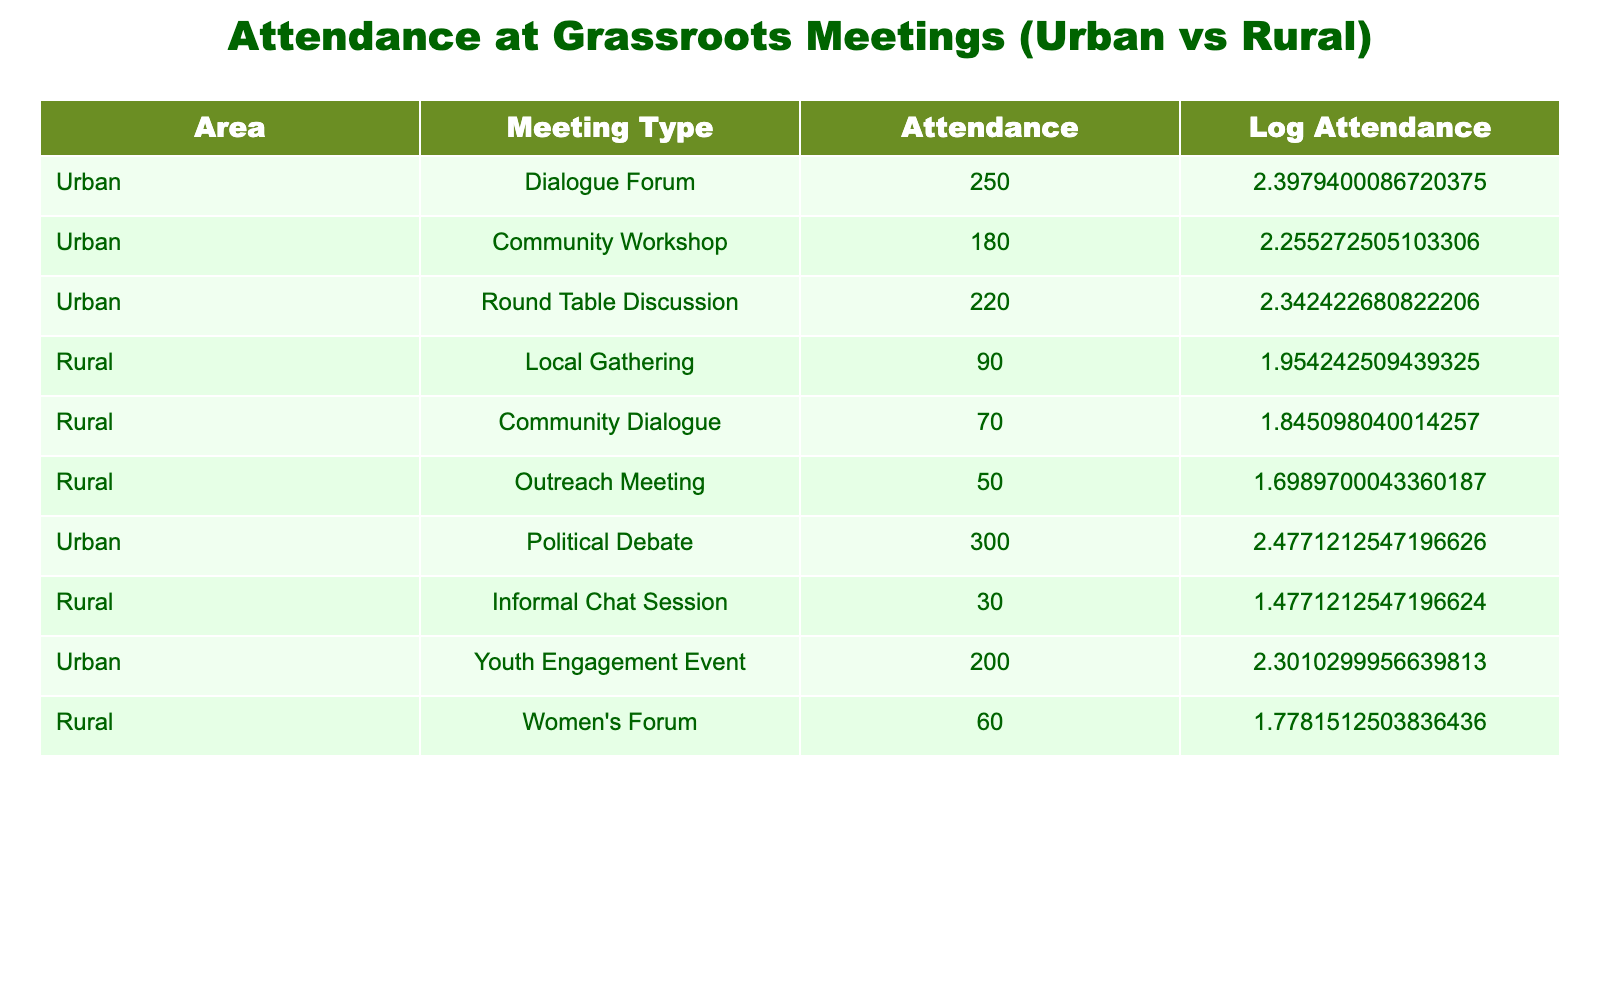What is the total attendance for urban meetings? To find the total attendance for urban meetings, sum the attendance values for all urban meeting types: 250 (Dialogue Forum) + 180 (Community Workshop) + 220 (Round Table Discussion) + 300 (Political Debate) + 200 (Youth Engagement Event) = 1150.
Answer: 1150 What is the attendance at the Rural Informal Chat Session? The attendance figure for the Rural Informal Chat Session is listed directly in the table, which shows an attendance of 30.
Answer: 30 Is the average attendance for rural meetings higher than for urban meetings? To determine this, calculate the average for each. For rural, add 90 (Local Gathering) + 70 (Community Dialogue) + 50 (Outreach Meeting) + 30 (Informal Chat Session) + 60 (Women’s Forum) = 300, then divide by 5 = 60. For urban, add 250 + 180 + 220 + 300 + 200 = 1150, then divide by 5 = 230. Since 60 is not higher than 230, the claim is false.
Answer: No Which meeting type had the highest attendance? Looking at the attendance numbers, the Political Debate in urban areas has the highest attendance at 300.
Answer: 300 What is the difference in attendance between the highest and lowest rural meeting? The highest rural meeting is the Local Gathering with 90 attendees, while the lowest is the Informal Chat Session with 30. The difference is 90 - 30 = 60.
Answer: 60 What percentage of total attendance comes from urban meetings? The total attendance is 1150 (from urban) + 300 (from rural) = 1450. The percentage from urban meetings is (1150 / 1450) * 100 = 79.31%.
Answer: 79.31% Did more than 200 people attend the Community Workshop? The attendance for the Community Workshop is 180, which is less than 200, so the statement is false.
Answer: No What is the total attendance for all types of meetings? Add all attendance figures: 250 (Urban Dialogue Forum) + 180 (Community Workshop) + 220 (Round Table Discussion) + 90 (Rural Local Gathering) + 70 (Community Dialogue) + 50 (Outreach Meeting) + 300 (Political Debate) + 30 (Informal Chat Session) + 200 (Youth Engagement Event) + 60 (Women’s Forum) = 1450.
Answer: 1450 